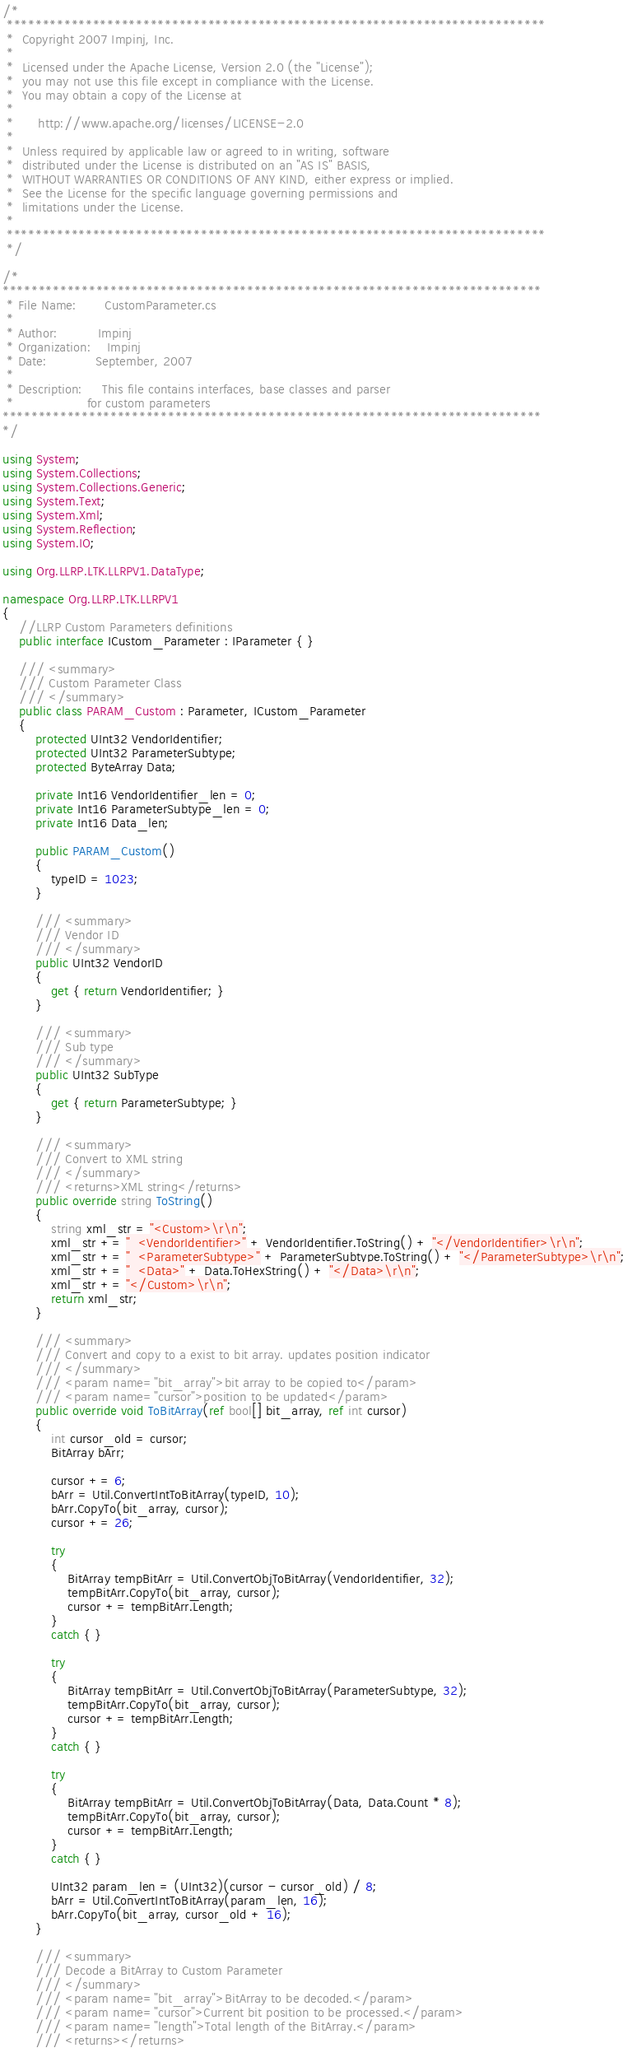<code> <loc_0><loc_0><loc_500><loc_500><_C#_>/*
 ***************************************************************************
 *  Copyright 2007 Impinj, Inc.
 *
 *  Licensed under the Apache License, Version 2.0 (the "License");
 *  you may not use this file except in compliance with the License.
 *  You may obtain a copy of the License at
 *
 *      http://www.apache.org/licenses/LICENSE-2.0
 *
 *  Unless required by applicable law or agreed to in writing, software
 *  distributed under the License is distributed on an "AS IS" BASIS,
 *  WITHOUT WARRANTIES OR CONDITIONS OF ANY KIND, either express or implied.
 *  See the License for the specific language governing permissions and
 *  limitations under the License.
 *
 ***************************************************************************
 */

/*
***************************************************************************
 * File Name:       CustomParameter.cs
 *
 * Author:          Impinj
 * Organization:    Impinj
 * Date:            September, 2007
 *
 * Description:     This file contains interfaces, base classes and parser
 *                  for custom parameters
***************************************************************************
*/

using System;
using System.Collections;
using System.Collections.Generic;
using System.Text;
using System.Xml;
using System.Reflection;
using System.IO;

using Org.LLRP.LTK.LLRPV1.DataType;

namespace Org.LLRP.LTK.LLRPV1
{
    //LLRP Custom Parameters definitions
    public interface ICustom_Parameter : IParameter { }

    /// <summary>
    /// Custom Parameter Class
    /// </summary>
    public class PARAM_Custom : Parameter, ICustom_Parameter
    {
        protected UInt32 VendorIdentifier;
        protected UInt32 ParameterSubtype;
        protected ByteArray Data;

        private Int16 VendorIdentifier_len = 0;
        private Int16 ParameterSubtype_len = 0;
        private Int16 Data_len;

        public PARAM_Custom()
        {
            typeID = 1023;
        }

        /// <summary>
        /// Vendor ID
        /// </summary>
        public UInt32 VendorID
        {
            get { return VendorIdentifier; }
        }

        /// <summary>
        /// Sub type
        /// </summary>
        public UInt32 SubType
        {
            get { return ParameterSubtype; }
        }

        /// <summary>
        /// Convert to XML string
        /// </summary>
        /// <returns>XML string</returns>
        public override string ToString()
        {
            string xml_str = "<Custom>\r\n";
            xml_str += "  <VendorIdentifier>" + VendorIdentifier.ToString() + "</VendorIdentifier>\r\n";
            xml_str += "  <ParameterSubtype>" + ParameterSubtype.ToString() + "</ParameterSubtype>\r\n";
            xml_str += "  <Data>" + Data.ToHexString() + "</Data>\r\n";
            xml_str += "</Custom>\r\n";
            return xml_str;
        }

        /// <summary>
        /// Convert and copy to a exist to bit array. updates position indicator
        /// </summary>
        /// <param name="bit_array">bit array to be copied to</param>
        /// <param name="cursor">position to be updated</param>
        public override void ToBitArray(ref bool[] bit_array, ref int cursor)
        {
            int cursor_old = cursor;
            BitArray bArr;

            cursor += 6;
            bArr = Util.ConvertIntToBitArray(typeID, 10);
            bArr.CopyTo(bit_array, cursor);
            cursor += 26;

            try
            {
                BitArray tempBitArr = Util.ConvertObjToBitArray(VendorIdentifier, 32);
                tempBitArr.CopyTo(bit_array, cursor);
                cursor += tempBitArr.Length;
            }
            catch { }

            try
            {
                BitArray tempBitArr = Util.ConvertObjToBitArray(ParameterSubtype, 32);
                tempBitArr.CopyTo(bit_array, cursor);
                cursor += tempBitArr.Length;
            }
            catch { }

            try
            {
                BitArray tempBitArr = Util.ConvertObjToBitArray(Data, Data.Count * 8);
                tempBitArr.CopyTo(bit_array, cursor);
                cursor += tempBitArr.Length;
            }
            catch { }

            UInt32 param_len = (UInt32)(cursor - cursor_old) / 8;
            bArr = Util.ConvertIntToBitArray(param_len, 16);
            bArr.CopyTo(bit_array, cursor_old + 16);
        }

        /// <summary>
        /// Decode a BitArray to Custom Parameter
        /// </summary>
        /// <param name="bit_array">BitArray to be decoded.</param>
        /// <param name="cursor">Current bit position to be processed.</param>
        /// <param name="length">Total length of the BitArray.</param>
        /// <returns></returns></code> 